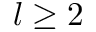<formula> <loc_0><loc_0><loc_500><loc_500>l \geq 2</formula> 